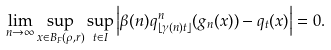<formula> <loc_0><loc_0><loc_500><loc_500>\lim _ { n \rightarrow \infty } \sup _ { x \in B _ { F } ( \rho , r ) } \sup _ { t \in I } \left | \beta ( n ) q ^ { n } _ { \lfloor \gamma ( n ) t \rfloor } ( g _ { n } ( x ) ) - q _ { t } ( x ) \right | = 0 .</formula> 